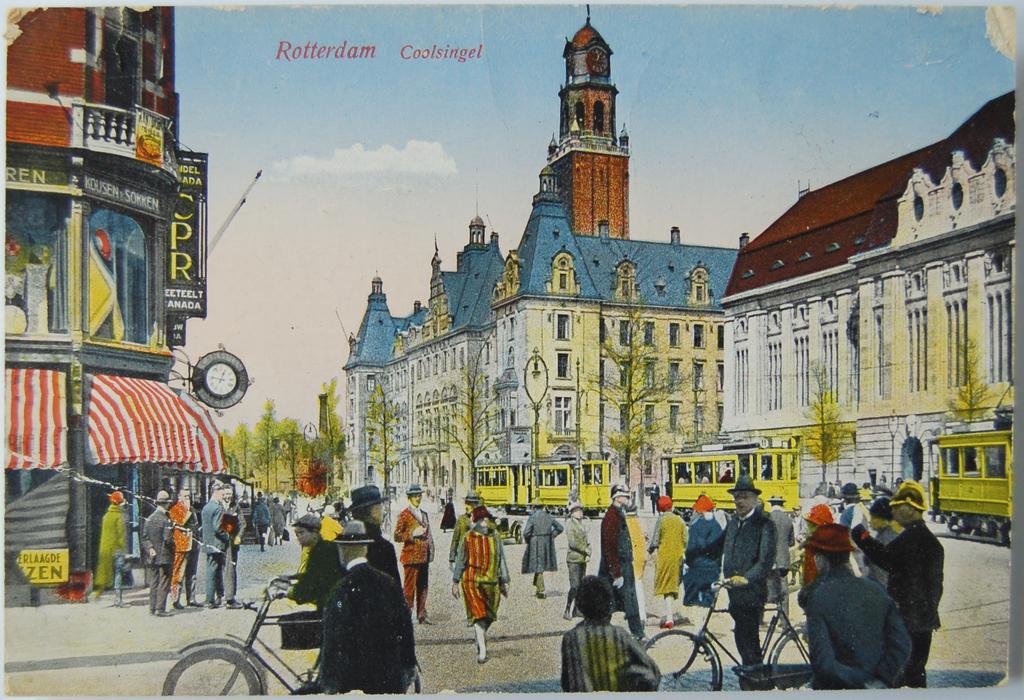Please provide a concise description of this image. This image is a painting. In this image there are buildings and trees. At the bottom there are people and there are vehicles on the road. In the background there is sky and we can see text. There are boards. 